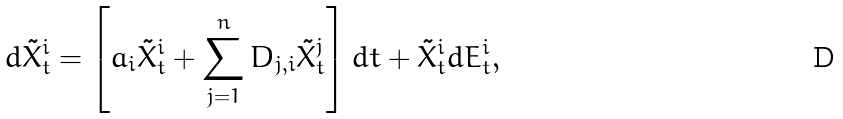Convert formula to latex. <formula><loc_0><loc_0><loc_500><loc_500>d \tilde { X } _ { t } ^ { i } = \left [ a _ { i } \tilde { X } _ { t } ^ { i } + \sum _ { j = 1 } ^ { n } D _ { j , i } \tilde { X } _ { t } ^ { j } \right ] d t + \tilde { X } _ { t } ^ { i } d E _ { t } ^ { i } ,</formula> 